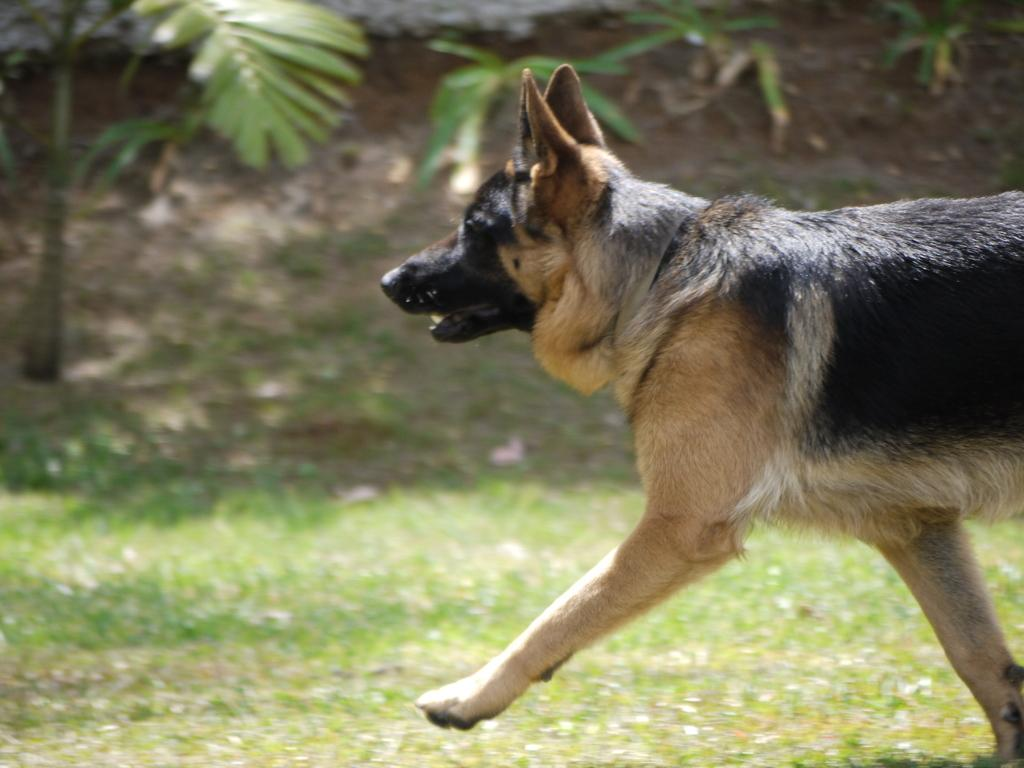What animal can be seen in the image? There is a dog in the image. What is the dog doing in the image? The dog is walking on the grass. What type of natural feature is visible in the background of the image? There is a mountain in the image. What other type of vegetation is present in the image? There are trees in the image. What type of ring can be seen on the dog's nose in the image? There is no ring present on the dog's nose in the image. Can you tell me how many bees are buzzing around the dog in the image? There are no bees present in the image; the focus is on the dog walking on the grass. 